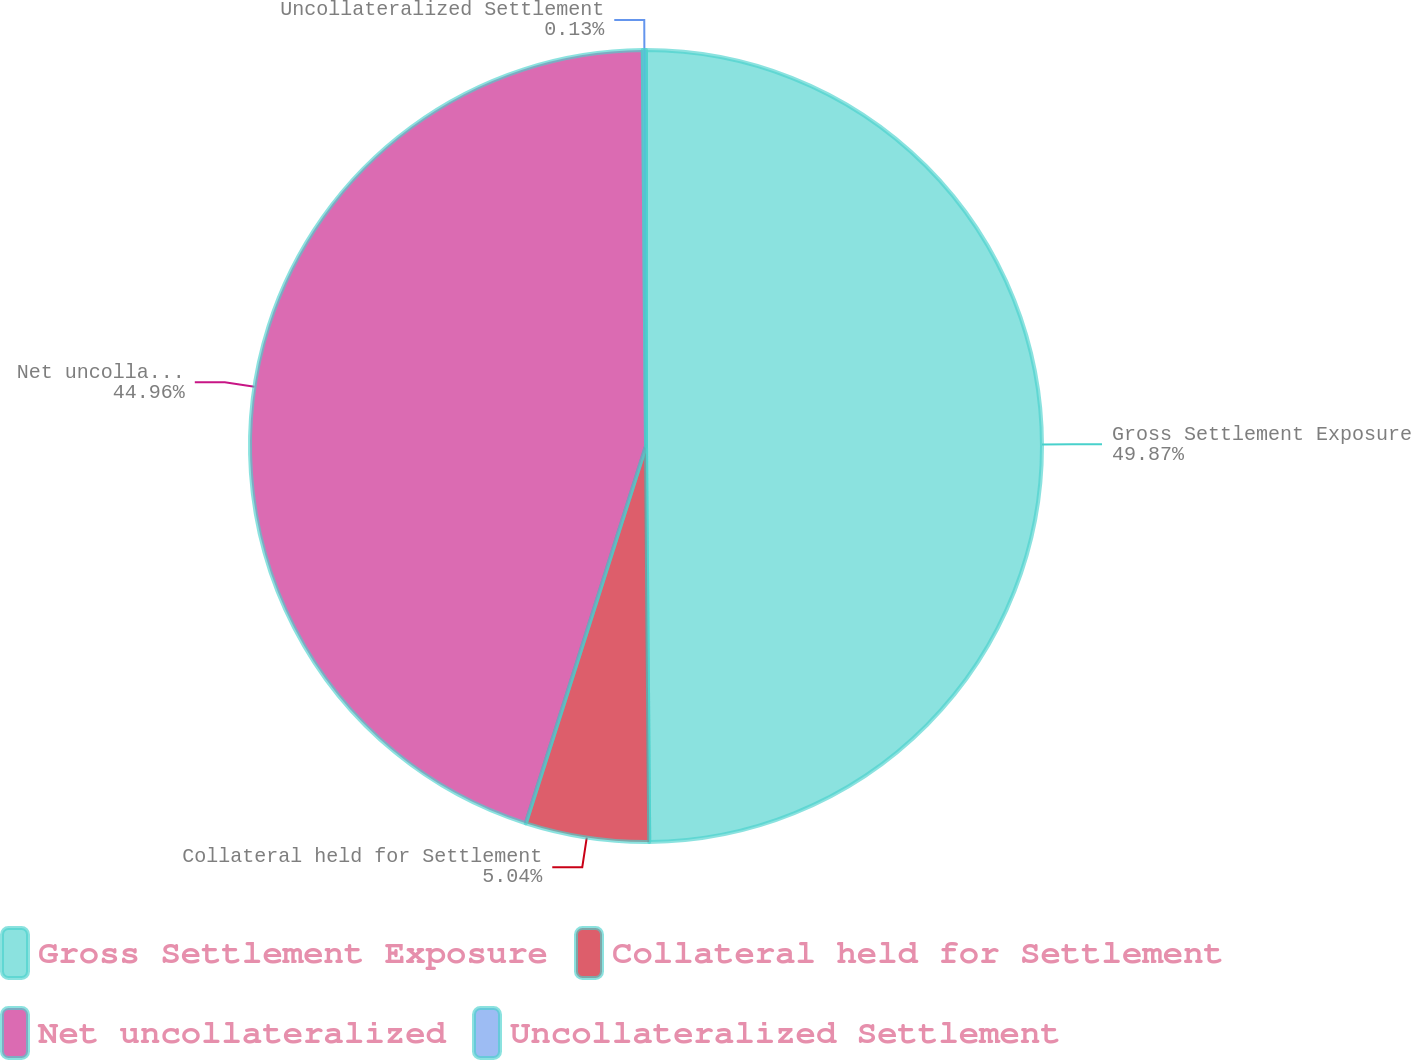Convert chart to OTSL. <chart><loc_0><loc_0><loc_500><loc_500><pie_chart><fcel>Gross Settlement Exposure<fcel>Collateral held for Settlement<fcel>Net uncollateralized<fcel>Uncollateralized Settlement<nl><fcel>49.87%<fcel>5.04%<fcel>44.96%<fcel>0.13%<nl></chart> 